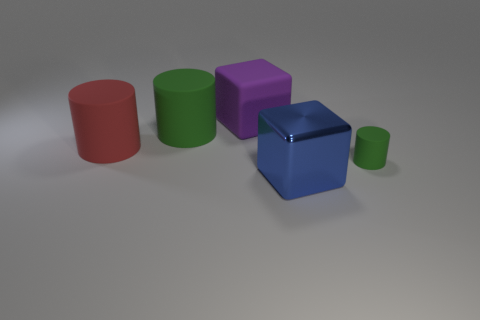How many red objects are metal cubes or tiny rubber objects?
Offer a very short reply. 0. There is a cylinder that is on the right side of the big blue object; what is its material?
Provide a short and direct response. Rubber. Are the green cylinder that is right of the blue object and the blue object made of the same material?
Your answer should be compact. No. The large blue thing has what shape?
Ensure brevity in your answer.  Cube. There is a green thing that is on the right side of the green rubber cylinder that is behind the big red object; how many big red cylinders are right of it?
Offer a very short reply. 0. What number of other objects are the same material as the large purple block?
Your answer should be compact. 3. What is the material of the purple block that is the same size as the red cylinder?
Give a very brief answer. Rubber. Is the color of the big cylinder that is to the right of the red thing the same as the big cube in front of the red rubber thing?
Offer a very short reply. No. Is there a purple matte thing that has the same shape as the big blue metallic object?
Make the answer very short. Yes. There is a green object that is the same size as the blue thing; what shape is it?
Keep it short and to the point. Cylinder. 